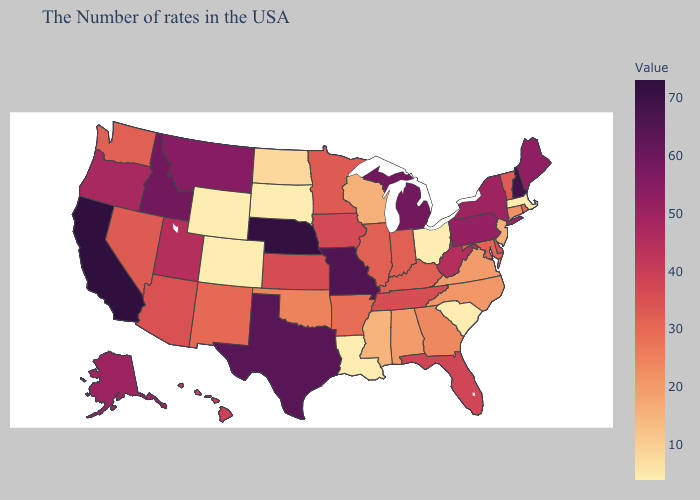Does South Dakota have the lowest value in the USA?
Keep it brief. Yes. Does the map have missing data?
Keep it brief. No. Among the states that border Arizona , which have the lowest value?
Be succinct. Colorado. Among the states that border Idaho , does Oregon have the lowest value?
Answer briefly. No. Does Nebraska have the highest value in the MidWest?
Write a very short answer. Yes. 